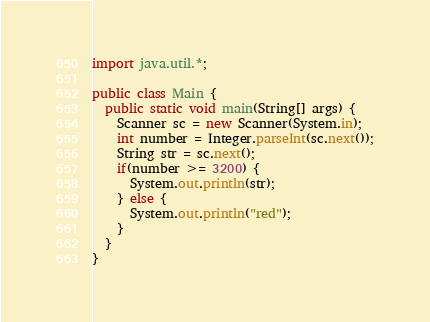<code> <loc_0><loc_0><loc_500><loc_500><_Java_>import java.util.*;

public class Main {
  public static void main(String[] args) {
    Scanner sc = new Scanner(System.in);
    int number = Integer.parseInt(sc.next());
    String str = sc.next();
    if(number >= 3200) {
      System.out.println(str);
    } else {
      System.out.println("red");
    }
  }
}
</code> 